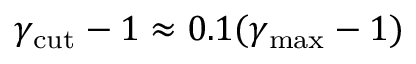<formula> <loc_0><loc_0><loc_500><loc_500>\gamma _ { c u t } - 1 \approx 0 . 1 ( \gamma _ { \max } - 1 )</formula> 